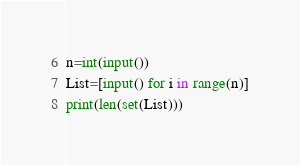Convert code to text. <code><loc_0><loc_0><loc_500><loc_500><_Python_>n=int(input())
List=[input() for i in range(n)]
print(len(set(List)))
</code> 